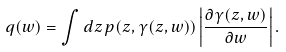<formula> <loc_0><loc_0><loc_500><loc_500>q ( w ) = \int d z \, p ( z , \gamma ( z , w ) ) \left | \frac { \partial \gamma ( z , w ) } { \partial w } \right | .</formula> 